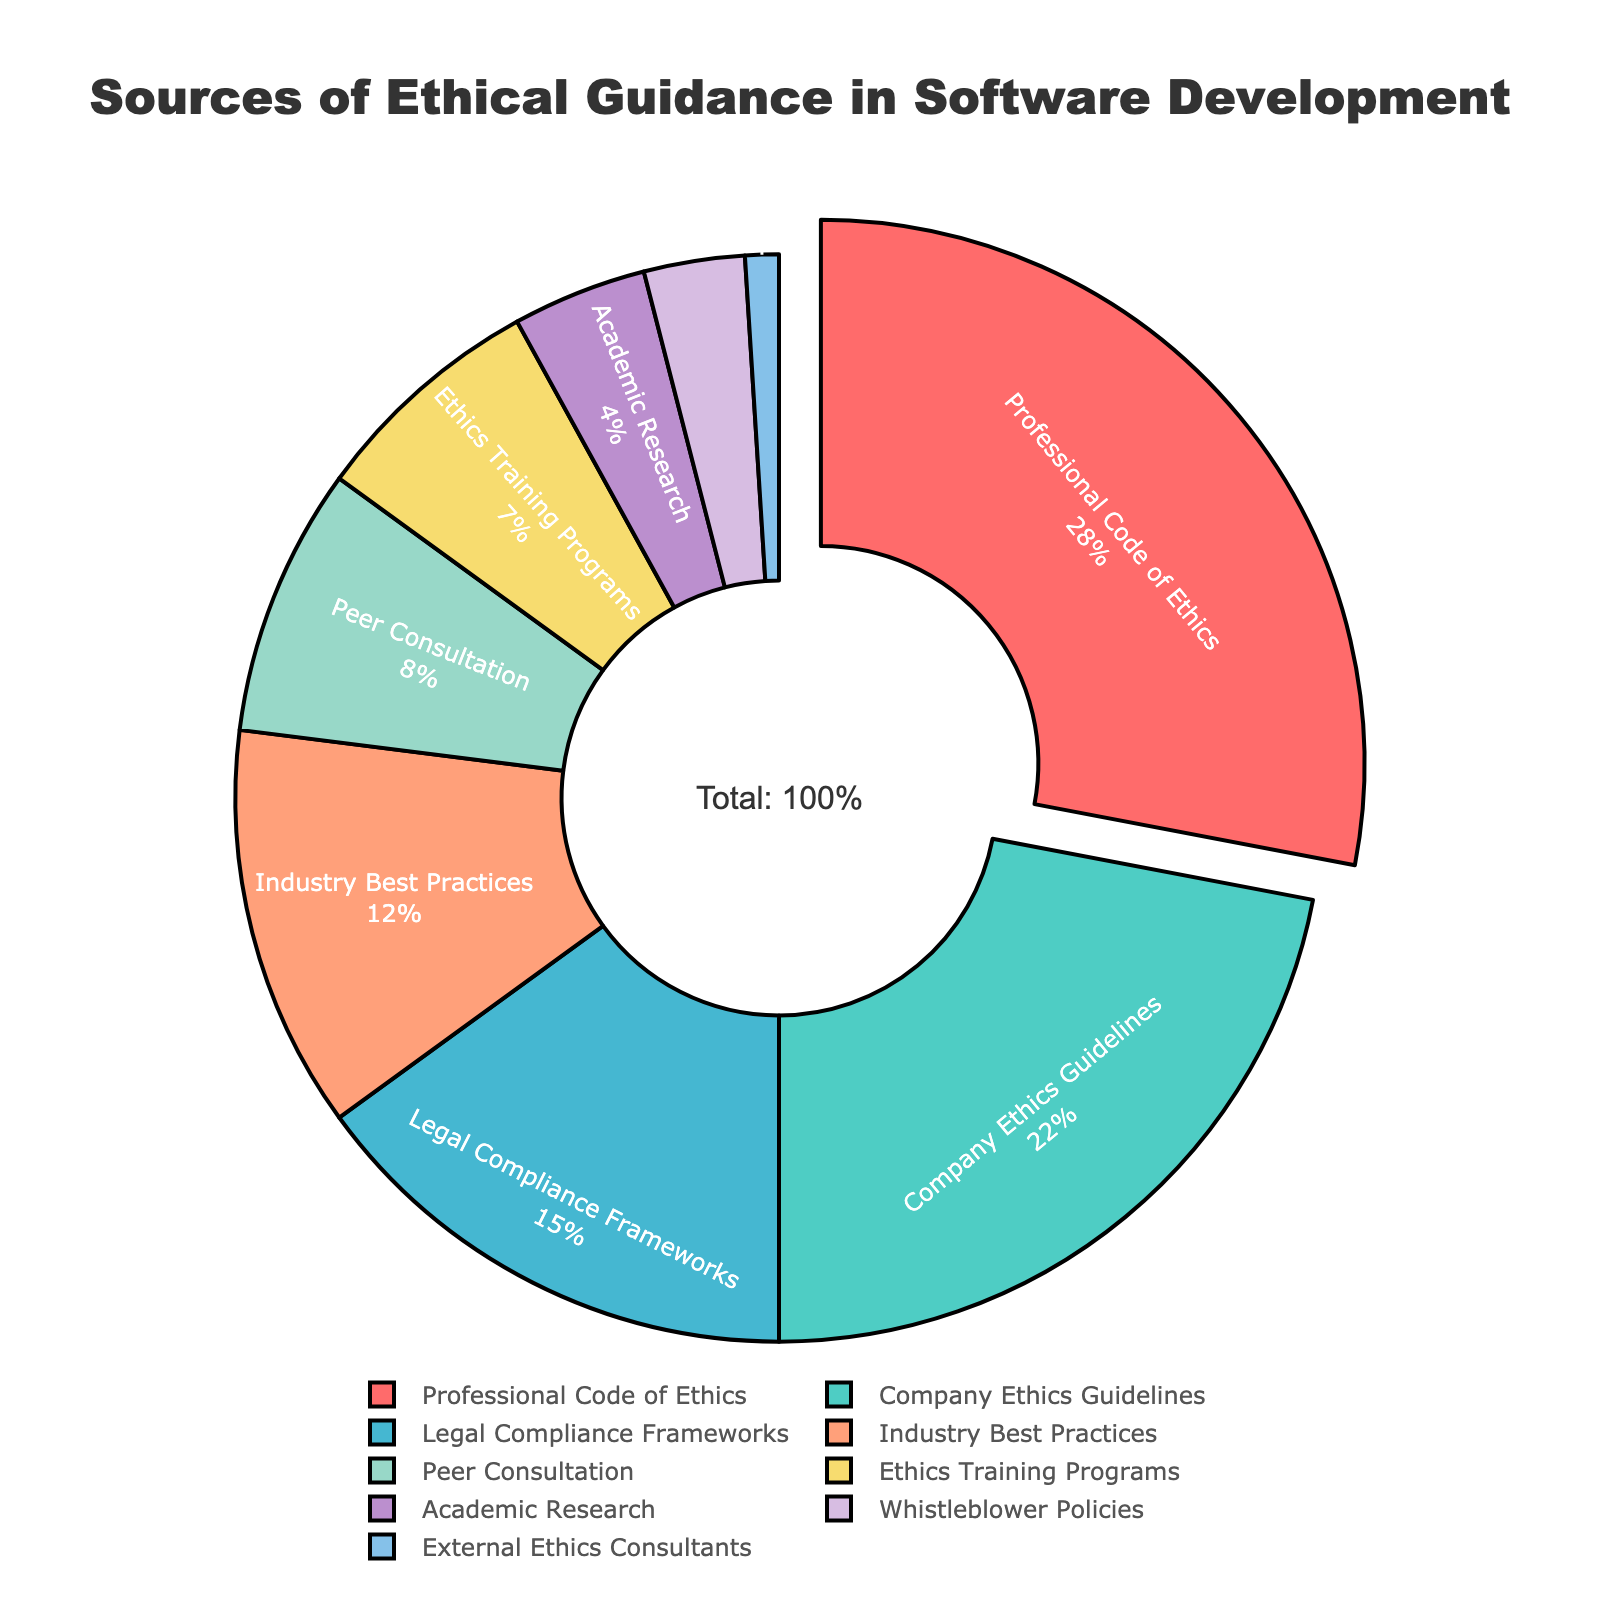Which source of ethical guidance is the most consulted by software development teams? The slice that is pulled out the most in the pie chart represents the most consulted source of ethical guidance. This slice is labeled "Professional Code of Ethics" with 28% of the total.
Answer: Professional Code of Ethics Which source of ethical guidance is the least consulted by software development teams? The smallest slice in the chart, which is marked "External Ethics Consultants," represents the least consulted source of ethical guidance. It accounts for 1% of the total.
Answer: External Ethics Consultants How much more frequently are "Professional Code of Ethics" consulted compared to "Legal Compliance Frameworks"? First, identify the percentages for both sources: "Professional Code of Ethics" is 28% and "Legal Compliance Frameworks" is 15%. Subtract the smaller percentage from the larger one: 28% - 15% = 13%.
Answer: 13% What is the combined percentage of teams that consult "Company Ethics Guidelines" and "Industry Best Practices"? Add the two respective percentages together: "Company Ethics Guidelines" is 22% and "Industry Best Practices" is 12%. So, 22% + 12% = 34%.
Answer: 34% Do more teams consult "Peer Consultation" or "Ethics Training Programs"? "Peer Consultation" is 8%, which is larger than "Ethics Training Programs" at 7%.
Answer: Peer Consultation What percentage of sources of ethical guidance come from "Professional Code of Ethics", "Company Ethics Guidelines", and "Legal Compliance Frameworks" combined? Add the percentages of the three sources: 28% (Professional Code of Ethics) + 22% (Company Ethics Guidelines) + 15% (Legal Compliance Frameworks) = 65%.
Answer: 65% Which sources of ethical guidance together make up less than 10% of the total? The sources with percentages less than 10% are "Peer Consultation" at 8%, "Ethics Training Programs" at 7%, "Academic Research" at 4%, "Whistleblower Policies" at 3%, and "External Ethics Consultants" at 1%. Combined, they account for 8% + 7% + 4% + 3% + 1% = 23%, but listing them individually confirms they are all less than 10%.
Answer: Peer Consultation, Ethics Training Programs, Academic Research, Whistleblower Policies, External Ethics Consultants What sources of ethical guidance are represented with blue or green color tones? Observing the pie chart, the slices for "Company Ethics Guidelines" (blue-green) and "Industry Best Practices" (blue) fit this description.
Answer: Company Ethics Guidelines, Industry Best Practices 